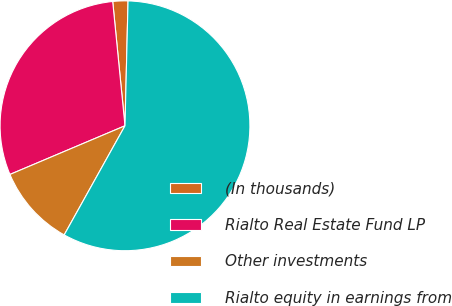Convert chart. <chart><loc_0><loc_0><loc_500><loc_500><pie_chart><fcel>(In thousands)<fcel>Rialto Real Estate Fund LP<fcel>Other investments<fcel>Rialto equity in earnings from<nl><fcel>1.96%<fcel>29.8%<fcel>10.54%<fcel>57.7%<nl></chart> 